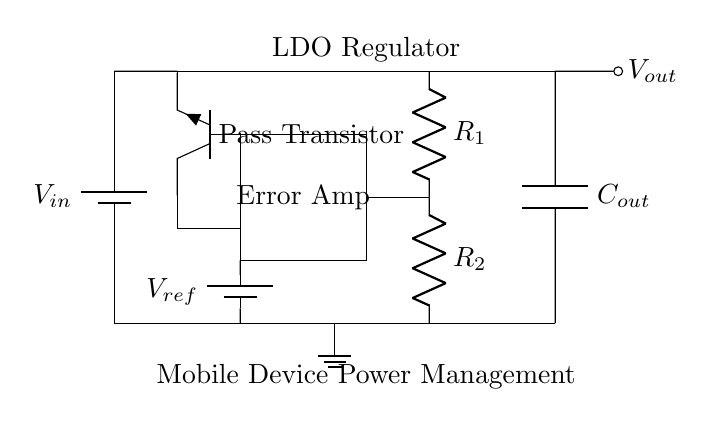What is the input voltage of the LDO regulator? The input voltage is indicated by the battery symbol labeled as V_in. This is the voltage supplied to the circuit from an external source.
Answer: V_in What type of transistor is used in this circuit? The diagram shows a pass transistor labeled Tnpn, which indicates it is an NPN transistor configured to control the output voltage based on the feedback.
Answer: NPN transistor What is the role of the error amplifier in this circuit? The error amplifier is responsible for comparing the output voltage with a reference voltage (V_ref) and adjusting the transistor's operation to maintain a stable output voltage.
Answer: Voltage regulation What are the values of the resistors in the feedback network? The circuit diagram includes two resistors labeled R_1 and R_2, which are part of the feedback network that sets the gain of the error amplifier and influences the output voltage. The specific values are not provided; however, they are necessary for tuning the output.
Answer: R_1 and R_2 How does the feedback network affect the output voltage? The feedback network allows a portion of the output voltage to be fed back to the input of the error amplifier. This feedback loop helps the regulator maintain a consistent output voltage by adjusting the base current of the pass transistor to counter variations in load or input voltage.
Answer: Maintains stability What component stabilizes the output voltage? The output capacitor, labeled C_out, smooths out fluctuations and helps in stabilizing the voltage at the output under varying load conditions.
Answer: Output capacitor What is the reference voltage value in the circuit? The reference voltage is indicated by the voltage source labeled V_ref in the circuit, which sets the target voltage that the regulator will maintain at the output. The specific value of V_ref is not shown in the diagram.
Answer: V_ref 